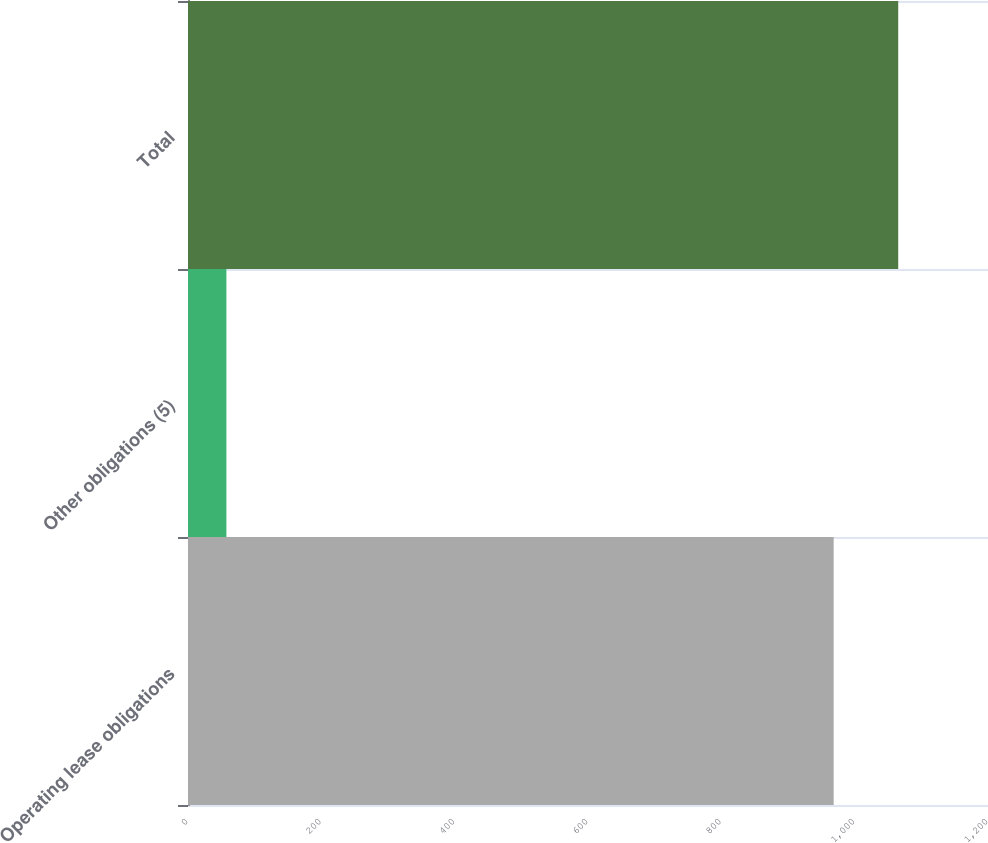Convert chart. <chart><loc_0><loc_0><loc_500><loc_500><bar_chart><fcel>Operating lease obligations<fcel>Other obligations (5)<fcel>Total<nl><fcel>968.5<fcel>57.6<fcel>1065.35<nl></chart> 